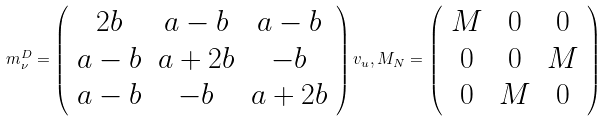Convert formula to latex. <formula><loc_0><loc_0><loc_500><loc_500>m ^ { D } _ { \nu } = \left ( \begin{array} { c c c } 2 b & a - b & a - b \\ a - b & a + 2 b & - b \\ a - b & - b & a + 2 b \end{array} \right ) v _ { u } , M _ { N } = \left ( \begin{array} { c c c } M & 0 & 0 \\ 0 & 0 & M \\ 0 & M & 0 \end{array} \right )</formula> 